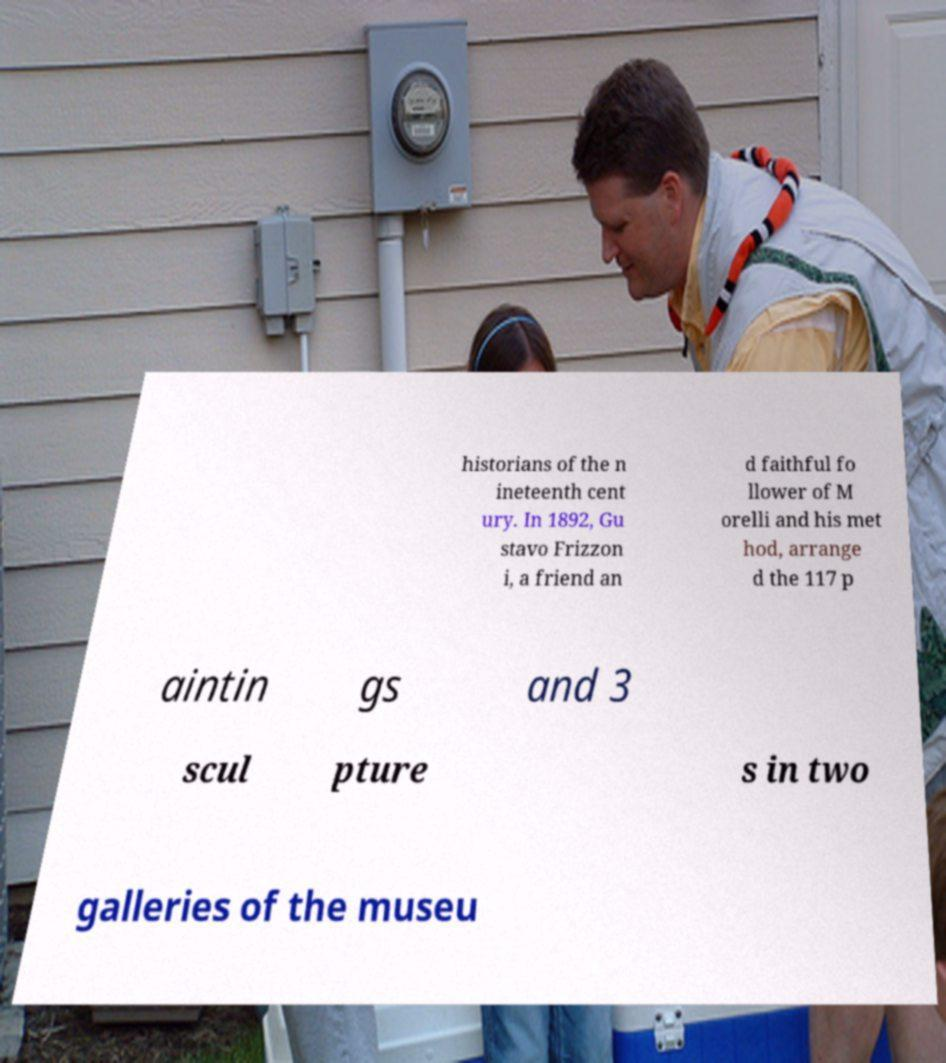Please identify and transcribe the text found in this image. historians of the n ineteenth cent ury. In 1892, Gu stavo Frizzon i, a friend an d faithful fo llower of M orelli and his met hod, arrange d the 117 p aintin gs and 3 scul pture s in two galleries of the museu 